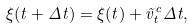Convert formula to latex. <formula><loc_0><loc_0><loc_500><loc_500>\xi ( t + \Delta t ) = \xi ( t ) + \vec { v } _ { t } ^ { c } \Delta t ,</formula> 